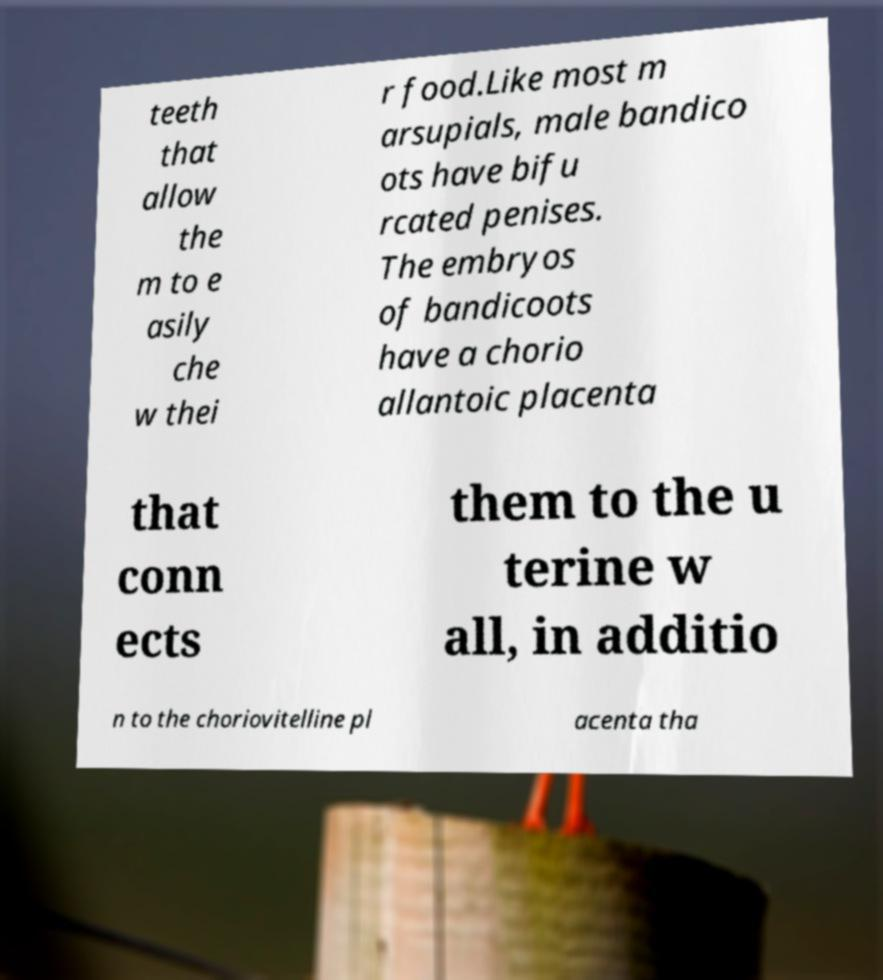Could you extract and type out the text from this image? teeth that allow the m to e asily che w thei r food.Like most m arsupials, male bandico ots have bifu rcated penises. The embryos of bandicoots have a chorio allantoic placenta that conn ects them to the u terine w all, in additio n to the choriovitelline pl acenta tha 